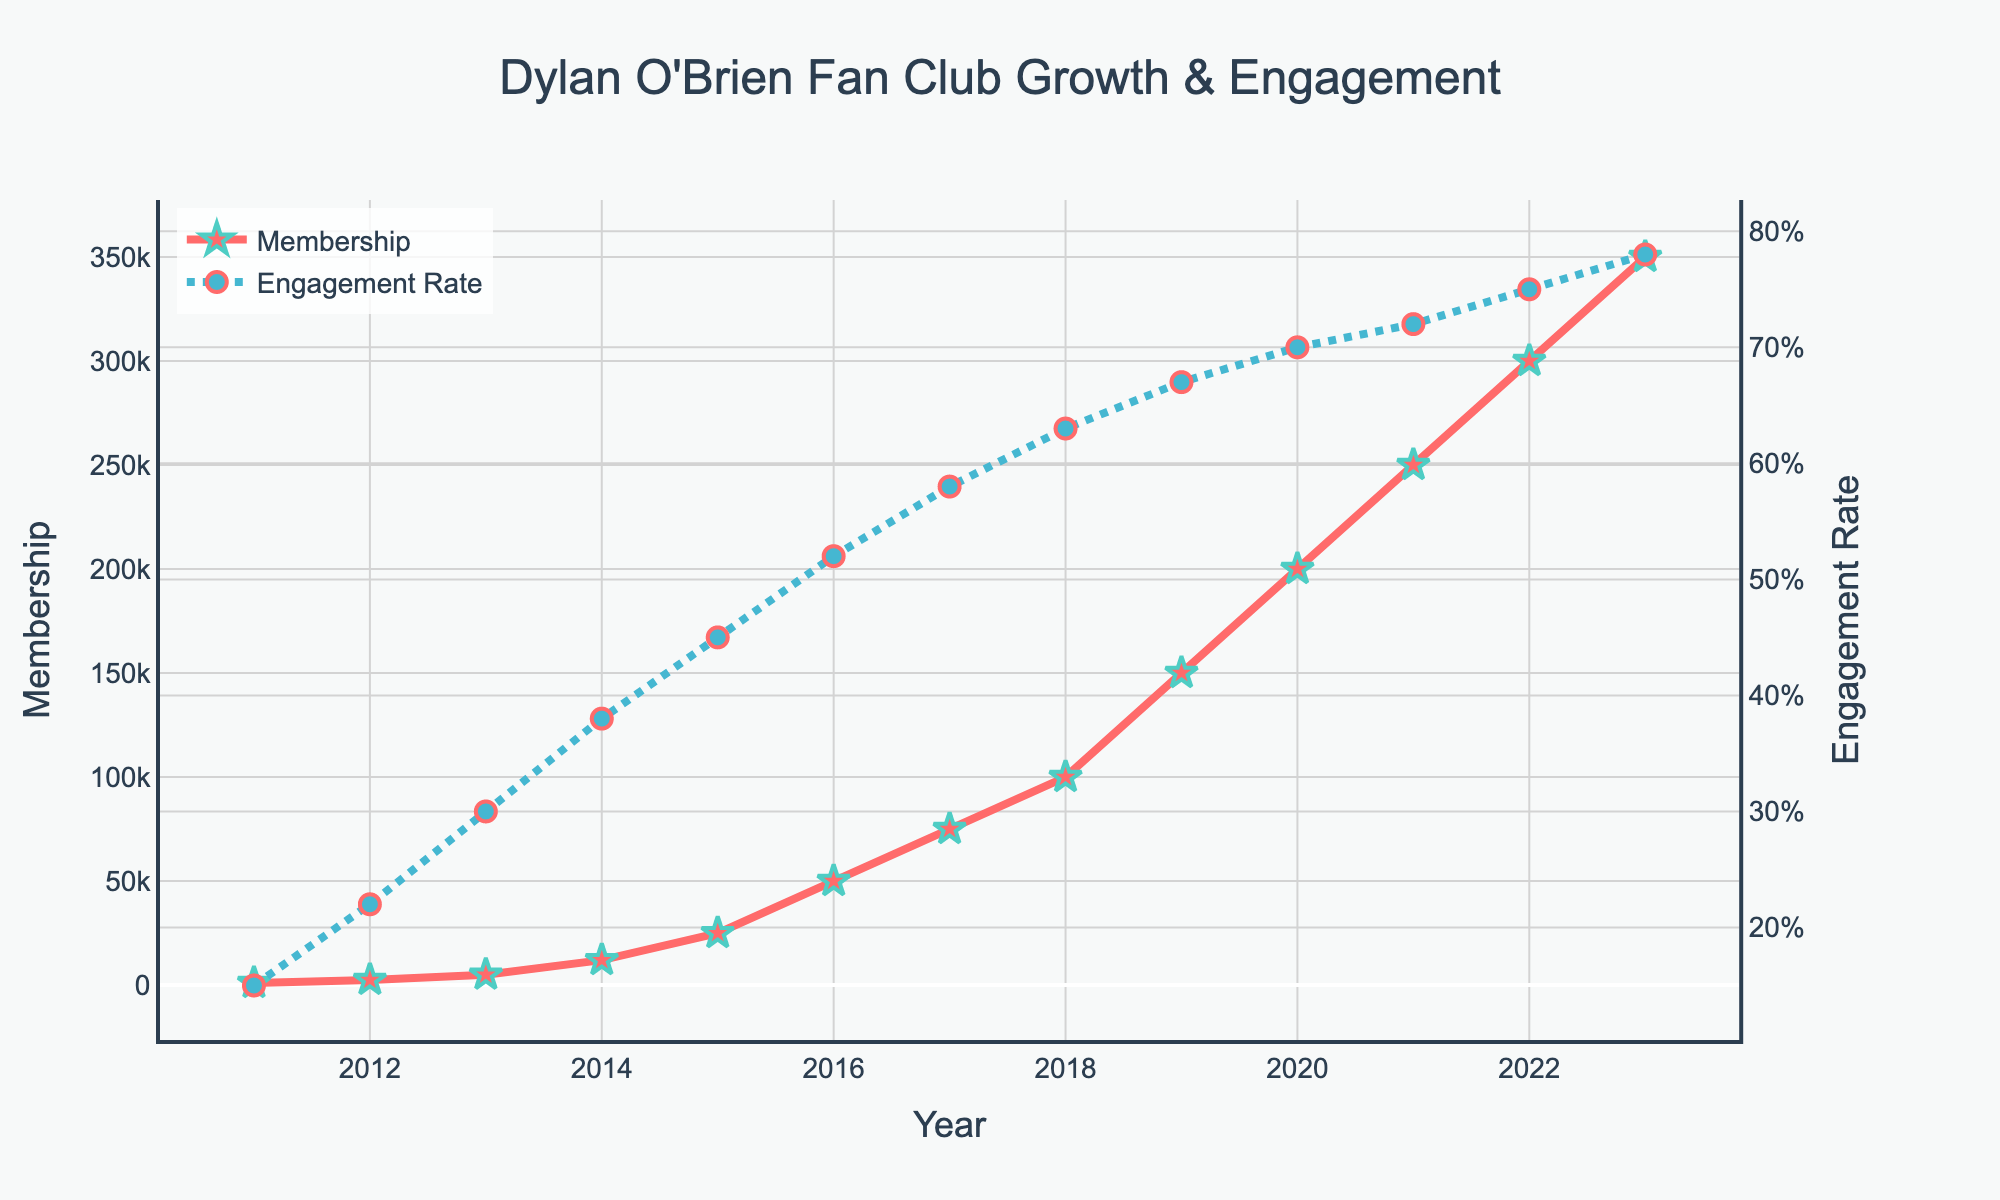How many years saw a growth in both membership and engagement rate? Identify the years where both the membership and engagement rate increased compared to the previous year. From 2011 to 2023, both metrics increase every year.
Answer: 12 In what year did the club membership first exceed 100,000? Look at the membership line for the first year where the value exceeds 100,000. This occurs in 2018.
Answer: 2018 Between which two consecutive years was the greatest increase in membership observed? Calculate the yearly differences in membership: 1500 (2011-2012), 2500 (2012-2013), 7000 (2013-2014), 13000 (2014-2015), 25000 (2015-2016), 25000 (2016-2017), 25000 (2017-2018), 50000 (2018-2019), 50000 (2019-2020), 50000 (2020-2021), 50000 (2021-2022), 50000 (2022-2023). The greatest increase is between 2018 and 2019.
Answer: 2018-2019 By how much did the engagement rate improve from 2015 to 2020? Subtract the engagement rate in 2015 (0.45) from the engagement rate in 2020 (0.70). The difference is 0.70 - 0.45.
Answer: 0.25 What is the average annual growth rate of membership between 2011 and 2023? First calculate total growth: 350,000 (2023) - 1,000 (2011) = 349,000. Then divide by number of years: 349,000 / (2023 - 2011) = 349,000 / 12 ≈ 29,083.33.
Answer: 29,083.33 How does the engagement rate in 2023 compare to that in 2011? Check the engagement rate in 2023 (0.78) and in 2011 (0.15). Subtract 0.15 from 0.78.
Answer: 0.63 Which year had the lowest engagement rate and what was that rate? The engagement rate is lowest in 2011.
Answer: 2011, 0.15 Does the color of the membership line or engagement rate line make it easier to differentiate between the two metrics? The membership line is red and the engagement rate line is blue, which are distinct and easily differentiable.
Answer: Yes Is there a point where the engagement rate increases but membership does not? Check if there is any year where engagement rate increases and membership does not grow. Both metrics increase every year, no such point exists.
Answer: No Between which two years did the engagement rate show the smallest increase? Calculate the yearly differences in engagement rate: 0.07 (2011-2012), 0.08 (2012-2013), 0.08 (2013-2014), 0.07 (2014-2015), 0.07 (2015-2016), 0.06 (2016-2017), 0.05 (2017-2018), 0.04 (2018-2019), 0.03 (2019-2020), 0.02 (2020-2021), 0.03 (2021-2022), 0.03 (2022-2023). The smallest increase is between 2020 and 2021.
Answer: 2020-2021 